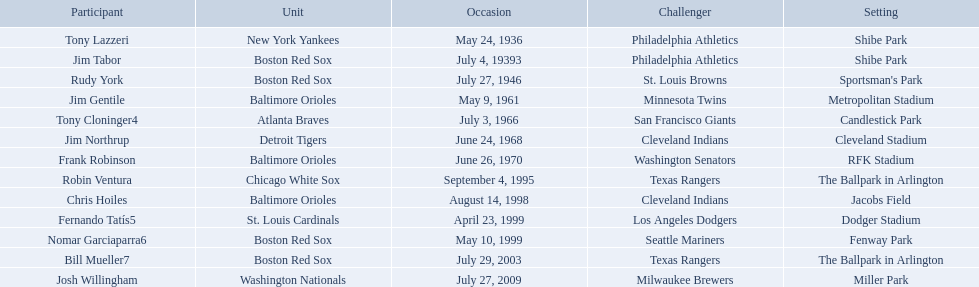Which teams faced off at miller park? Washington Nationals, Milwaukee Brewers. 